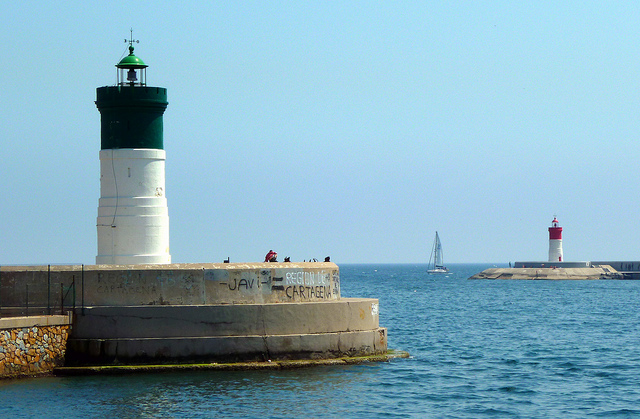What time of day does it appear to be? Given the bright lighting and shadows, it appears to be midday. The sun is shining, and visibility is excellent for navigation. 